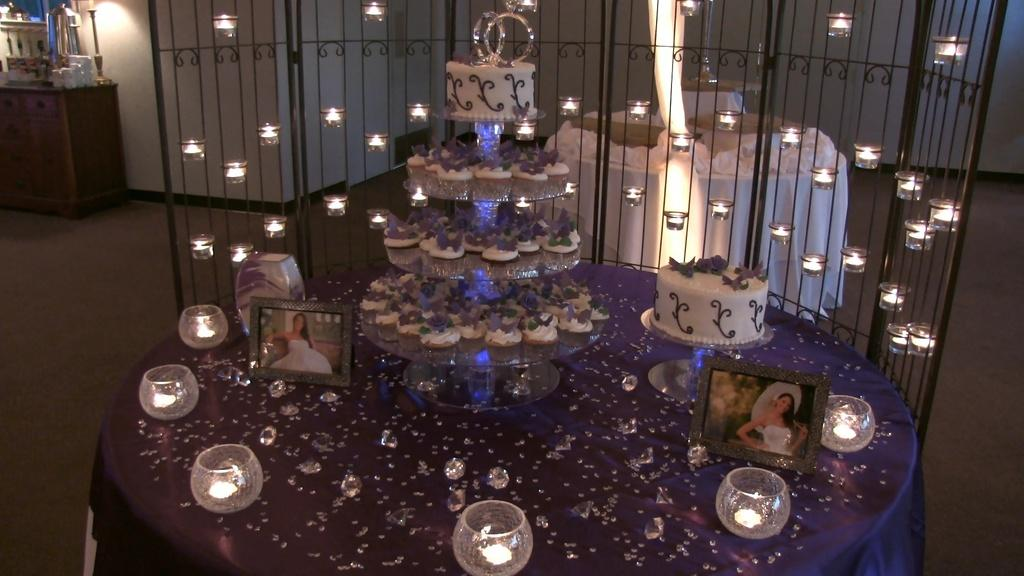What type of objects can be seen on the table in the image? There are candles, cakes, and frames on the table in the image. What is the primary purpose of the candles and cakes in the image? The candles and cakes are likely for a celebration or event. Can you describe the table in the background of the image? There is a table in the background of the image, but it is not clear what objects are on it. What other objects can be seen in the background of the image? There is a desk and other unspecified objects in the background of the image. What type of space vehicle can be seen in the image? There is no space vehicle present in the image; it features candles, cakes, frames, and other objects on tables and a desk. How many trucks are visible in the image? There are no trucks visible in the image. 